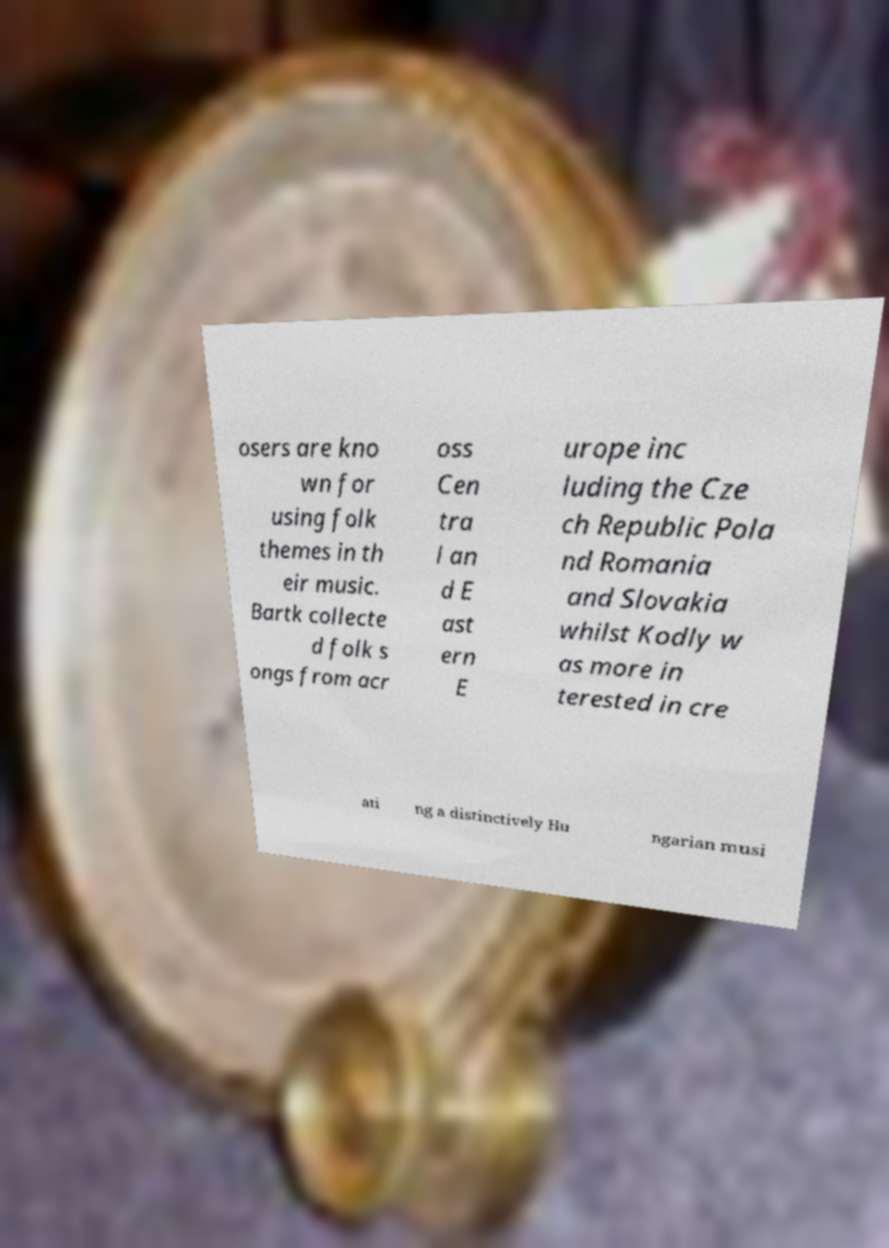Could you assist in decoding the text presented in this image and type it out clearly? osers are kno wn for using folk themes in th eir music. Bartk collecte d folk s ongs from acr oss Cen tra l an d E ast ern E urope inc luding the Cze ch Republic Pola nd Romania and Slovakia whilst Kodly w as more in terested in cre ati ng a distinctively Hu ngarian musi 